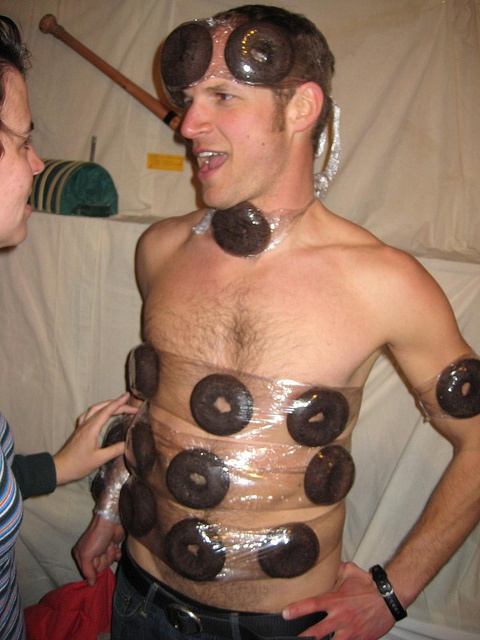Describe the objects in this image and their specific colors. I can see people in maroon, black, brown, and tan tones, people in maroon, gray, and black tones, donut in maroon, black, and gray tones, baseball bat in maroon, gray, and black tones, and donut in maroon, black, and gray tones in this image. 